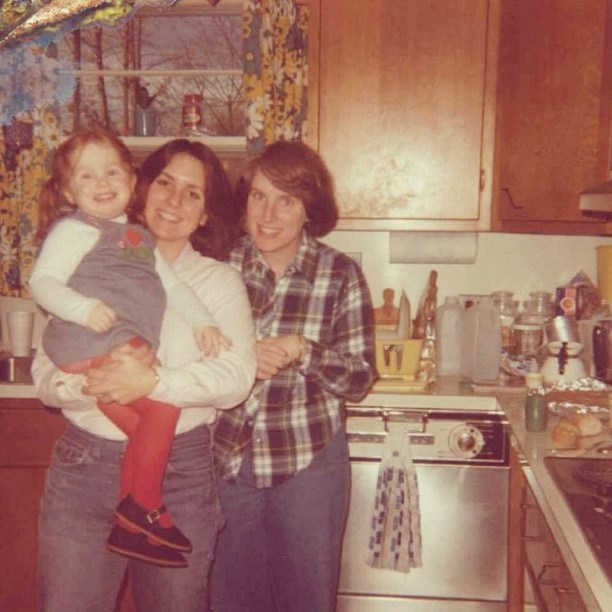Describe the objects in this image and their specific colors. I can see people in purple, brown, and tan tones, people in purple and brown tones, oven in purple, brown, and tan tones, people in purple, gray, beige, and tan tones, and sink in purple and brown tones in this image. 